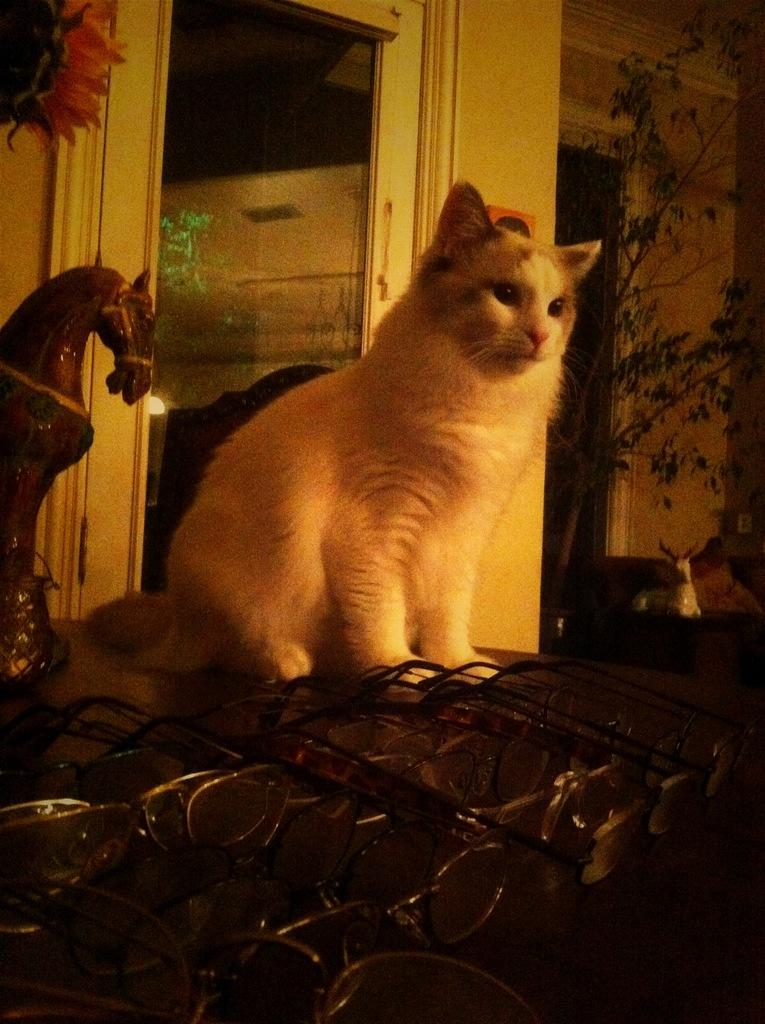What type of animal is in the image? There is a cat in the image. Can you describe the appearance of the cat? The cat is white and brown in color. What other objects can be seen in the image? There are glasses and a horse toy visible in the image. What can be seen in the background of the image? There is a building, a glass door, and a tree in the background. What is the name of the person who sent the parcel in the image? There is no parcel present in the image, so it is not possible to determine the name of the sender. 